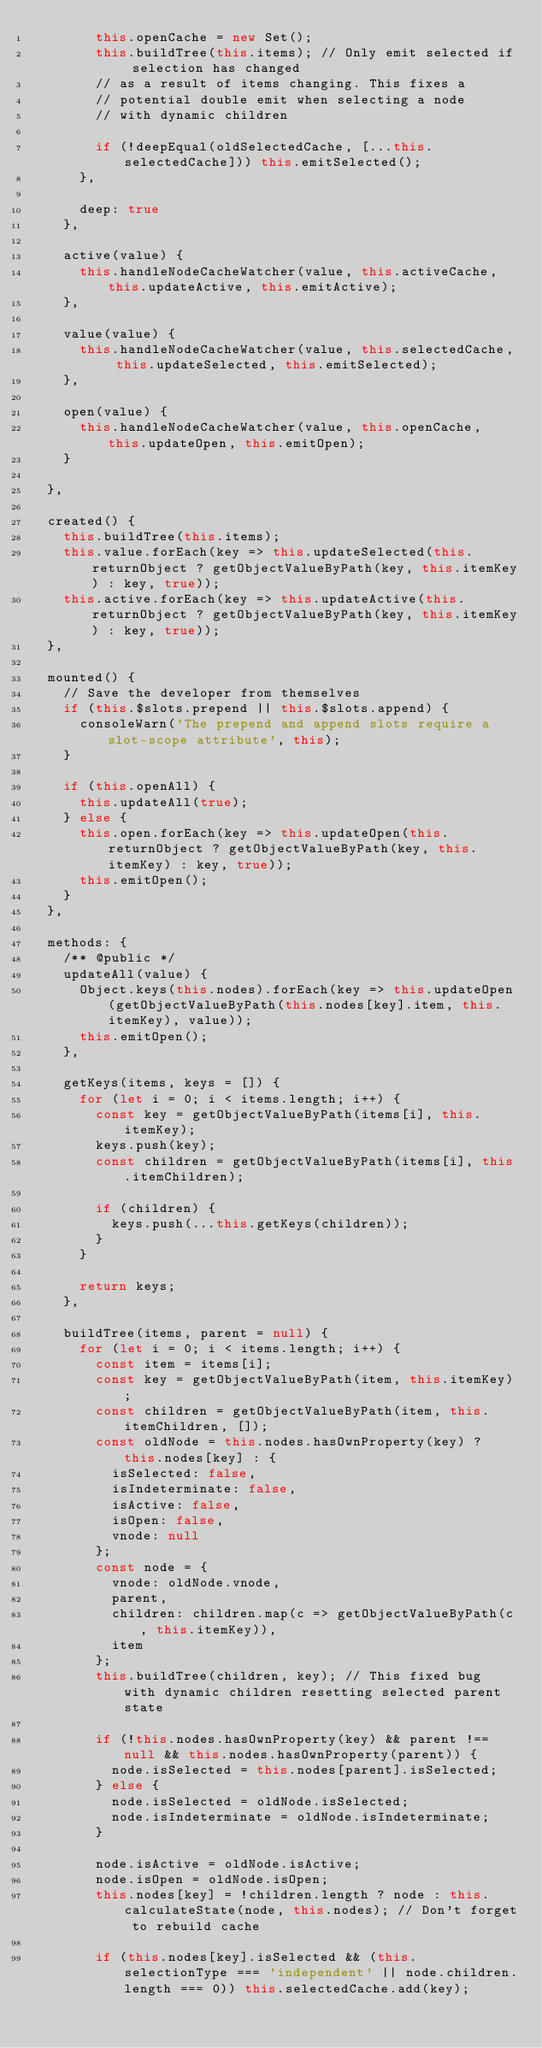<code> <loc_0><loc_0><loc_500><loc_500><_JavaScript_>        this.openCache = new Set();
        this.buildTree(this.items); // Only emit selected if selection has changed
        // as a result of items changing. This fixes a
        // potential double emit when selecting a node
        // with dynamic children

        if (!deepEqual(oldSelectedCache, [...this.selectedCache])) this.emitSelected();
      },

      deep: true
    },

    active(value) {
      this.handleNodeCacheWatcher(value, this.activeCache, this.updateActive, this.emitActive);
    },

    value(value) {
      this.handleNodeCacheWatcher(value, this.selectedCache, this.updateSelected, this.emitSelected);
    },

    open(value) {
      this.handleNodeCacheWatcher(value, this.openCache, this.updateOpen, this.emitOpen);
    }

  },

  created() {
    this.buildTree(this.items);
    this.value.forEach(key => this.updateSelected(this.returnObject ? getObjectValueByPath(key, this.itemKey) : key, true));
    this.active.forEach(key => this.updateActive(this.returnObject ? getObjectValueByPath(key, this.itemKey) : key, true));
  },

  mounted() {
    // Save the developer from themselves
    if (this.$slots.prepend || this.$slots.append) {
      consoleWarn('The prepend and append slots require a slot-scope attribute', this);
    }

    if (this.openAll) {
      this.updateAll(true);
    } else {
      this.open.forEach(key => this.updateOpen(this.returnObject ? getObjectValueByPath(key, this.itemKey) : key, true));
      this.emitOpen();
    }
  },

  methods: {
    /** @public */
    updateAll(value) {
      Object.keys(this.nodes).forEach(key => this.updateOpen(getObjectValueByPath(this.nodes[key].item, this.itemKey), value));
      this.emitOpen();
    },

    getKeys(items, keys = []) {
      for (let i = 0; i < items.length; i++) {
        const key = getObjectValueByPath(items[i], this.itemKey);
        keys.push(key);
        const children = getObjectValueByPath(items[i], this.itemChildren);

        if (children) {
          keys.push(...this.getKeys(children));
        }
      }

      return keys;
    },

    buildTree(items, parent = null) {
      for (let i = 0; i < items.length; i++) {
        const item = items[i];
        const key = getObjectValueByPath(item, this.itemKey);
        const children = getObjectValueByPath(item, this.itemChildren, []);
        const oldNode = this.nodes.hasOwnProperty(key) ? this.nodes[key] : {
          isSelected: false,
          isIndeterminate: false,
          isActive: false,
          isOpen: false,
          vnode: null
        };
        const node = {
          vnode: oldNode.vnode,
          parent,
          children: children.map(c => getObjectValueByPath(c, this.itemKey)),
          item
        };
        this.buildTree(children, key); // This fixed bug with dynamic children resetting selected parent state

        if (!this.nodes.hasOwnProperty(key) && parent !== null && this.nodes.hasOwnProperty(parent)) {
          node.isSelected = this.nodes[parent].isSelected;
        } else {
          node.isSelected = oldNode.isSelected;
          node.isIndeterminate = oldNode.isIndeterminate;
        }

        node.isActive = oldNode.isActive;
        node.isOpen = oldNode.isOpen;
        this.nodes[key] = !children.length ? node : this.calculateState(node, this.nodes); // Don't forget to rebuild cache

        if (this.nodes[key].isSelected && (this.selectionType === 'independent' || node.children.length === 0)) this.selectedCache.add(key);</code> 